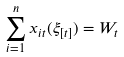<formula> <loc_0><loc_0><loc_500><loc_500>\sum _ { i = 1 } ^ { n } x _ { i t } ( \xi _ { [ t ] } ) = W _ { t }</formula> 